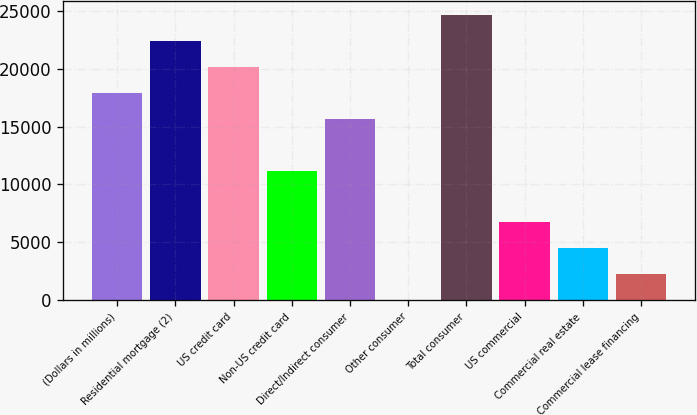<chart> <loc_0><loc_0><loc_500><loc_500><bar_chart><fcel>(Dollars in millions)<fcel>Residential mortgage (2)<fcel>US credit card<fcel>Non-US credit card<fcel>Direct/Indirect consumer<fcel>Other consumer<fcel>Total consumer<fcel>US commercial<fcel>Commercial real estate<fcel>Commercial lease financing<nl><fcel>17903.6<fcel>22379<fcel>20141.3<fcel>11190.5<fcel>15665.9<fcel>2<fcel>24616.7<fcel>6715.1<fcel>4477.4<fcel>2239.7<nl></chart> 